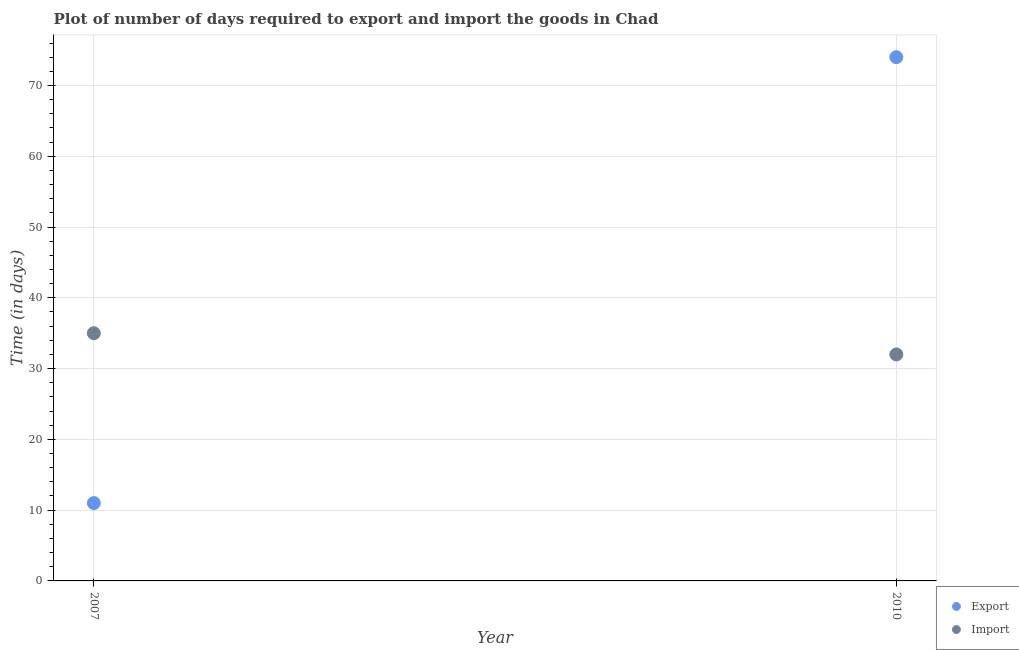Is the number of dotlines equal to the number of legend labels?
Keep it short and to the point. Yes. What is the time required to export in 2010?
Keep it short and to the point. 74. Across all years, what is the maximum time required to export?
Offer a very short reply. 74. Across all years, what is the minimum time required to import?
Provide a short and direct response. 32. In which year was the time required to import maximum?
Give a very brief answer. 2007. What is the total time required to export in the graph?
Ensure brevity in your answer.  85. What is the difference between the time required to export in 2007 and that in 2010?
Your answer should be very brief. -63. What is the difference between the time required to import in 2007 and the time required to export in 2010?
Offer a terse response. -39. What is the average time required to import per year?
Keep it short and to the point. 33.5. In the year 2007, what is the difference between the time required to import and time required to export?
Give a very brief answer. 24. What is the ratio of the time required to import in 2007 to that in 2010?
Your answer should be compact. 1.09. In how many years, is the time required to export greater than the average time required to export taken over all years?
Keep it short and to the point. 1. Does the time required to export monotonically increase over the years?
Your response must be concise. Yes. Is the time required to import strictly greater than the time required to export over the years?
Provide a succinct answer. No. What is the difference between two consecutive major ticks on the Y-axis?
Make the answer very short. 10. Are the values on the major ticks of Y-axis written in scientific E-notation?
Your answer should be compact. No. How many legend labels are there?
Keep it short and to the point. 2. What is the title of the graph?
Your answer should be compact. Plot of number of days required to export and import the goods in Chad. What is the label or title of the Y-axis?
Your answer should be very brief. Time (in days). What is the Time (in days) in Export in 2007?
Give a very brief answer. 11. What is the Time (in days) in Export in 2010?
Your answer should be compact. 74. What is the Time (in days) of Import in 2010?
Your answer should be very brief. 32. Across all years, what is the maximum Time (in days) of Export?
Provide a succinct answer. 74. Across all years, what is the minimum Time (in days) in Import?
Keep it short and to the point. 32. What is the difference between the Time (in days) in Export in 2007 and that in 2010?
Give a very brief answer. -63. What is the average Time (in days) of Export per year?
Keep it short and to the point. 42.5. What is the average Time (in days) of Import per year?
Offer a very short reply. 33.5. In the year 2007, what is the difference between the Time (in days) of Export and Time (in days) of Import?
Make the answer very short. -24. What is the ratio of the Time (in days) of Export in 2007 to that in 2010?
Provide a short and direct response. 0.15. What is the ratio of the Time (in days) in Import in 2007 to that in 2010?
Give a very brief answer. 1.09. What is the difference between the highest and the second highest Time (in days) in Export?
Your answer should be very brief. 63. What is the difference between the highest and the second highest Time (in days) in Import?
Offer a very short reply. 3. What is the difference between the highest and the lowest Time (in days) of Export?
Offer a terse response. 63. What is the difference between the highest and the lowest Time (in days) of Import?
Your answer should be compact. 3. 